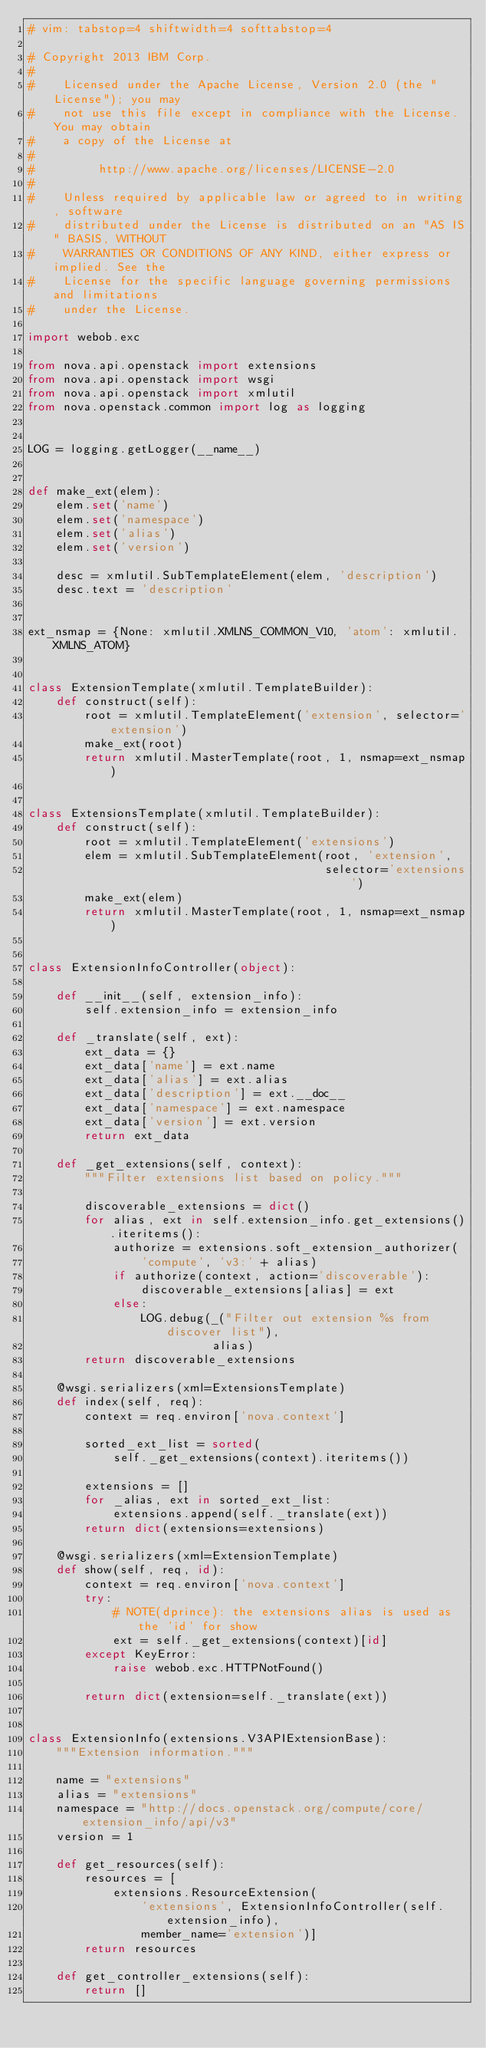<code> <loc_0><loc_0><loc_500><loc_500><_Python_># vim: tabstop=4 shiftwidth=4 softtabstop=4

# Copyright 2013 IBM Corp.
#
#    Licensed under the Apache License, Version 2.0 (the "License"); you may
#    not use this file except in compliance with the License. You may obtain
#    a copy of the License at
#
#         http://www.apache.org/licenses/LICENSE-2.0
#
#    Unless required by applicable law or agreed to in writing, software
#    distributed under the License is distributed on an "AS IS" BASIS, WITHOUT
#    WARRANTIES OR CONDITIONS OF ANY KIND, either express or implied. See the
#    License for the specific language governing permissions and limitations
#    under the License.

import webob.exc

from nova.api.openstack import extensions
from nova.api.openstack import wsgi
from nova.api.openstack import xmlutil
from nova.openstack.common import log as logging


LOG = logging.getLogger(__name__)


def make_ext(elem):
    elem.set('name')
    elem.set('namespace')
    elem.set('alias')
    elem.set('version')

    desc = xmlutil.SubTemplateElement(elem, 'description')
    desc.text = 'description'


ext_nsmap = {None: xmlutil.XMLNS_COMMON_V10, 'atom': xmlutil.XMLNS_ATOM}


class ExtensionTemplate(xmlutil.TemplateBuilder):
    def construct(self):
        root = xmlutil.TemplateElement('extension', selector='extension')
        make_ext(root)
        return xmlutil.MasterTemplate(root, 1, nsmap=ext_nsmap)


class ExtensionsTemplate(xmlutil.TemplateBuilder):
    def construct(self):
        root = xmlutil.TemplateElement('extensions')
        elem = xmlutil.SubTemplateElement(root, 'extension',
                                          selector='extensions')
        make_ext(elem)
        return xmlutil.MasterTemplate(root, 1, nsmap=ext_nsmap)


class ExtensionInfoController(object):

    def __init__(self, extension_info):
        self.extension_info = extension_info

    def _translate(self, ext):
        ext_data = {}
        ext_data['name'] = ext.name
        ext_data['alias'] = ext.alias
        ext_data['description'] = ext.__doc__
        ext_data['namespace'] = ext.namespace
        ext_data['version'] = ext.version
        return ext_data

    def _get_extensions(self, context):
        """Filter extensions list based on policy."""

        discoverable_extensions = dict()
        for alias, ext in self.extension_info.get_extensions().iteritems():
            authorize = extensions.soft_extension_authorizer(
                'compute', 'v3:' + alias)
            if authorize(context, action='discoverable'):
                discoverable_extensions[alias] = ext
            else:
                LOG.debug(_("Filter out extension %s from discover list"),
                          alias)
        return discoverable_extensions

    @wsgi.serializers(xml=ExtensionsTemplate)
    def index(self, req):
        context = req.environ['nova.context']

        sorted_ext_list = sorted(
            self._get_extensions(context).iteritems())

        extensions = []
        for _alias, ext in sorted_ext_list:
            extensions.append(self._translate(ext))
        return dict(extensions=extensions)

    @wsgi.serializers(xml=ExtensionTemplate)
    def show(self, req, id):
        context = req.environ['nova.context']
        try:
            # NOTE(dprince): the extensions alias is used as the 'id' for show
            ext = self._get_extensions(context)[id]
        except KeyError:
            raise webob.exc.HTTPNotFound()

        return dict(extension=self._translate(ext))


class ExtensionInfo(extensions.V3APIExtensionBase):
    """Extension information."""

    name = "extensions"
    alias = "extensions"
    namespace = "http://docs.openstack.org/compute/core/extension_info/api/v3"
    version = 1

    def get_resources(self):
        resources = [
            extensions.ResourceExtension(
                'extensions', ExtensionInfoController(self.extension_info),
                member_name='extension')]
        return resources

    def get_controller_extensions(self):
        return []
</code> 